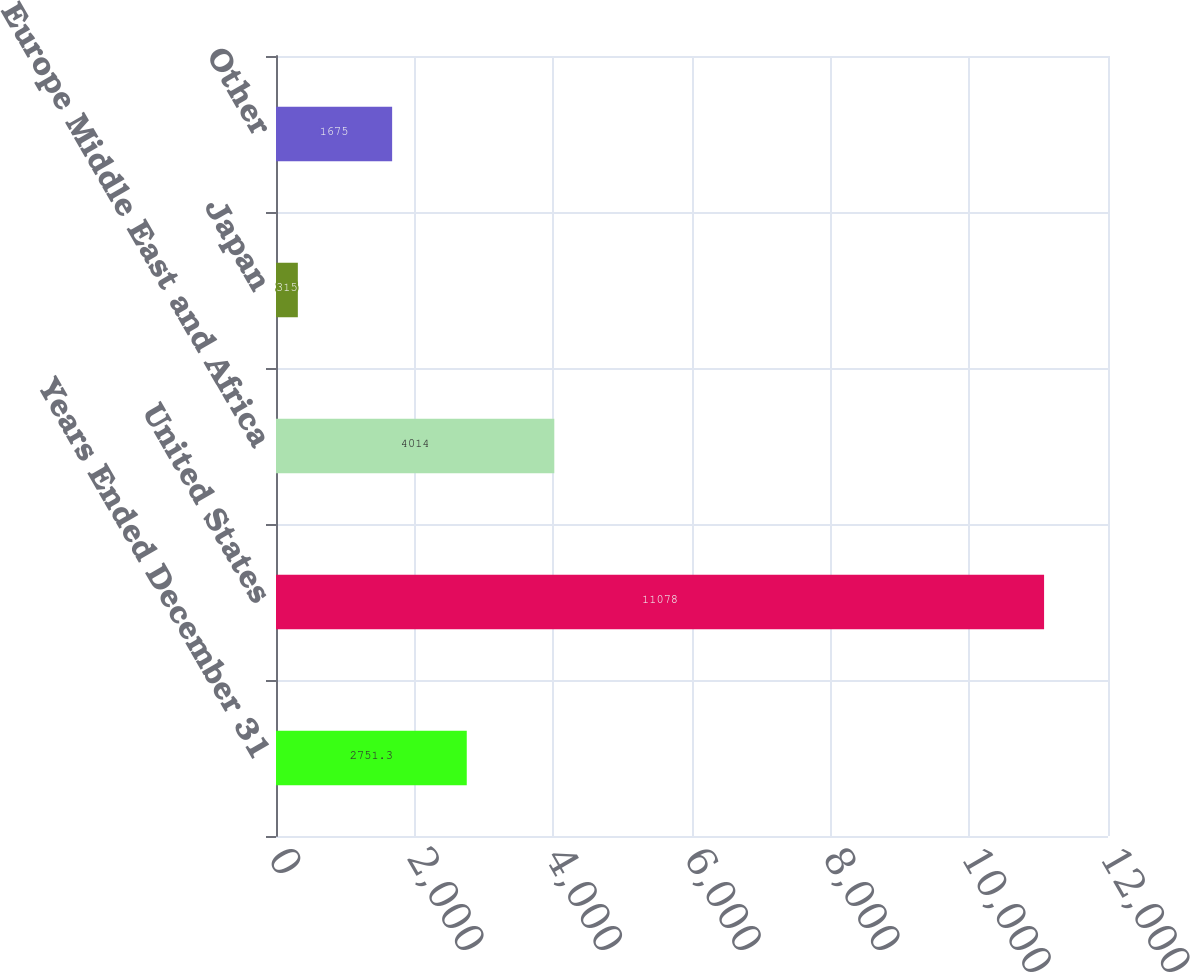Convert chart. <chart><loc_0><loc_0><loc_500><loc_500><bar_chart><fcel>Years Ended December 31<fcel>United States<fcel>Europe Middle East and Africa<fcel>Japan<fcel>Other<nl><fcel>2751.3<fcel>11078<fcel>4014<fcel>315<fcel>1675<nl></chart> 